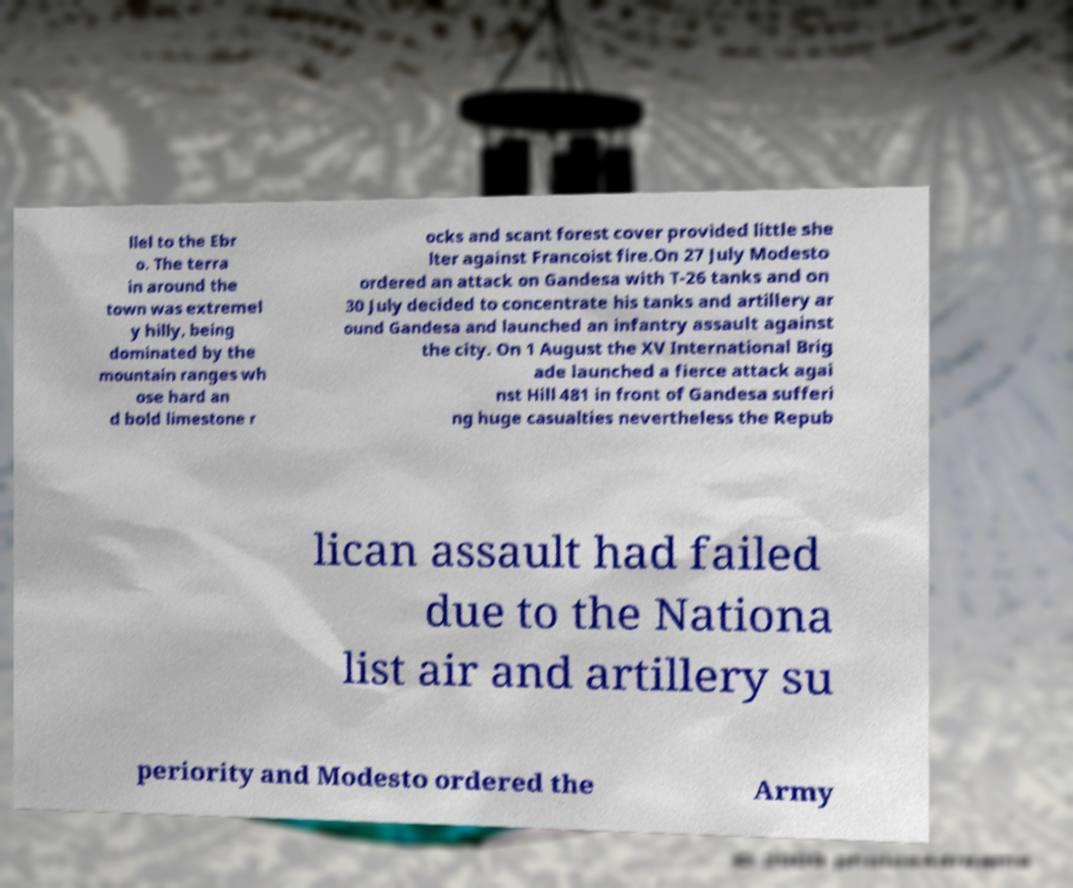Could you extract and type out the text from this image? llel to the Ebr o. The terra in around the town was extremel y hilly, being dominated by the mountain ranges wh ose hard an d bold limestone r ocks and scant forest cover provided little she lter against Francoist fire.On 27 July Modesto ordered an attack on Gandesa with T-26 tanks and on 30 July decided to concentrate his tanks and artillery ar ound Gandesa and launched an infantry assault against the city. On 1 August the XV International Brig ade launched a fierce attack agai nst Hill 481 in front of Gandesa sufferi ng huge casualties nevertheless the Repub lican assault had failed due to the Nationa list air and artillery su periority and Modesto ordered the Army 